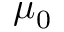Convert formula to latex. <formula><loc_0><loc_0><loc_500><loc_500>\mu _ { 0 }</formula> 